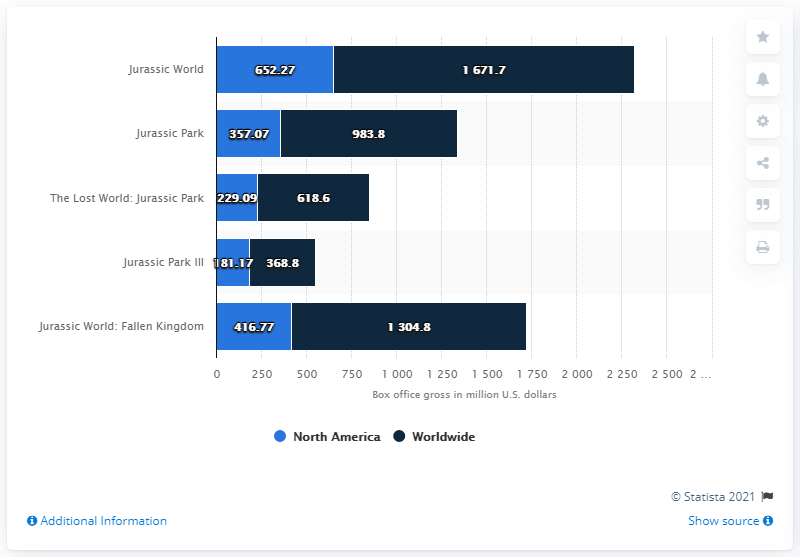Specify some key components in this picture. As of October 2018, the domestic gross box office revenue of "Jurassic World" stood at 652.27 million U.S. dollars. Jurassic Park is the fifth most successful movie series of all time based on global box office revenue. 